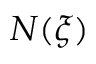<formula> <loc_0><loc_0><loc_500><loc_500>N ( \xi )</formula> 